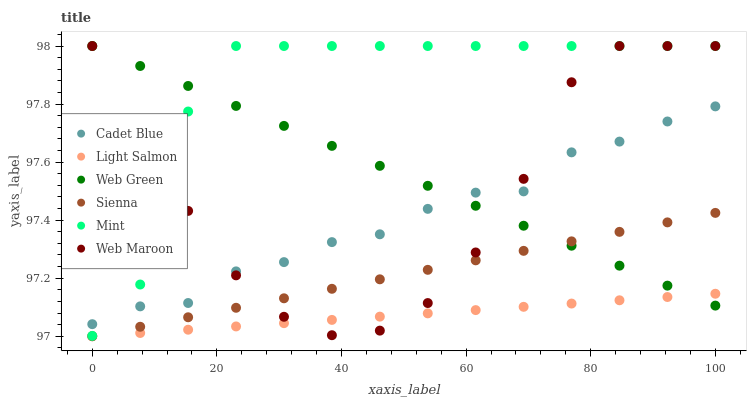Does Light Salmon have the minimum area under the curve?
Answer yes or no. Yes. Does Mint have the maximum area under the curve?
Answer yes or no. Yes. Does Cadet Blue have the minimum area under the curve?
Answer yes or no. No. Does Cadet Blue have the maximum area under the curve?
Answer yes or no. No. Is Sienna the smoothest?
Answer yes or no. Yes. Is Mint the roughest?
Answer yes or no. Yes. Is Cadet Blue the smoothest?
Answer yes or no. No. Is Cadet Blue the roughest?
Answer yes or no. No. Does Light Salmon have the lowest value?
Answer yes or no. Yes. Does Cadet Blue have the lowest value?
Answer yes or no. No. Does Mint have the highest value?
Answer yes or no. Yes. Does Cadet Blue have the highest value?
Answer yes or no. No. Is Sienna less than Cadet Blue?
Answer yes or no. Yes. Is Mint greater than Sienna?
Answer yes or no. Yes. Does Mint intersect Web Green?
Answer yes or no. Yes. Is Mint less than Web Green?
Answer yes or no. No. Is Mint greater than Web Green?
Answer yes or no. No. Does Sienna intersect Cadet Blue?
Answer yes or no. No. 